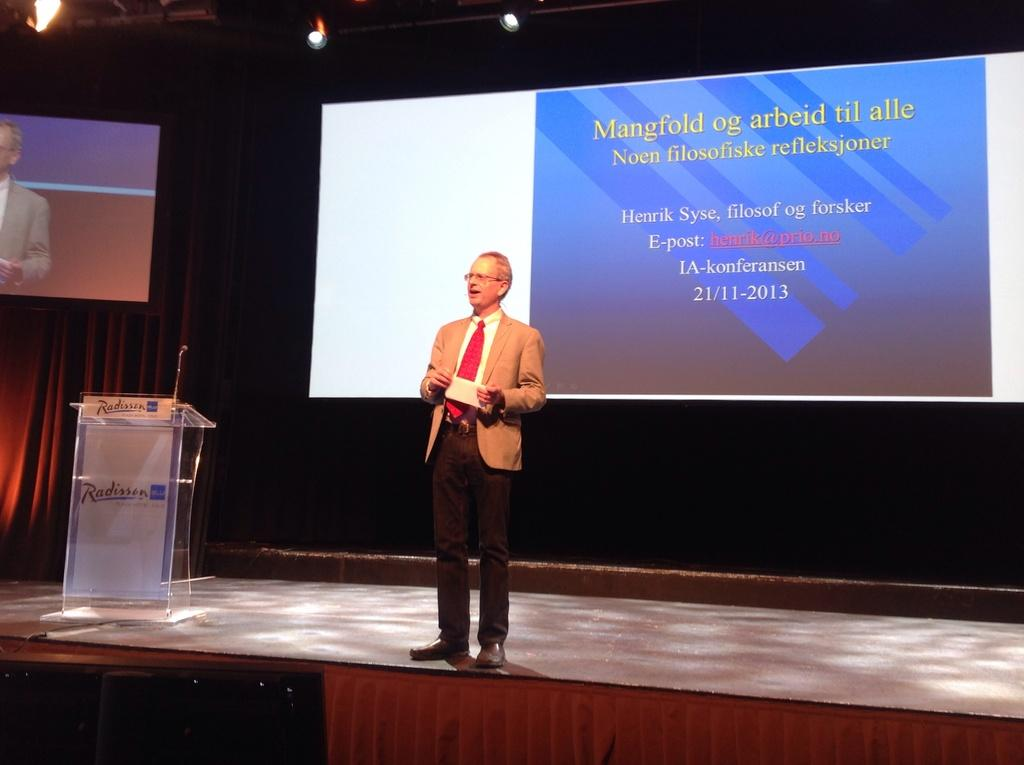Provide a one-sentence caption for the provided image. A man stands on stage at a Radisson hotel presenting with slides on a screen behind him. 